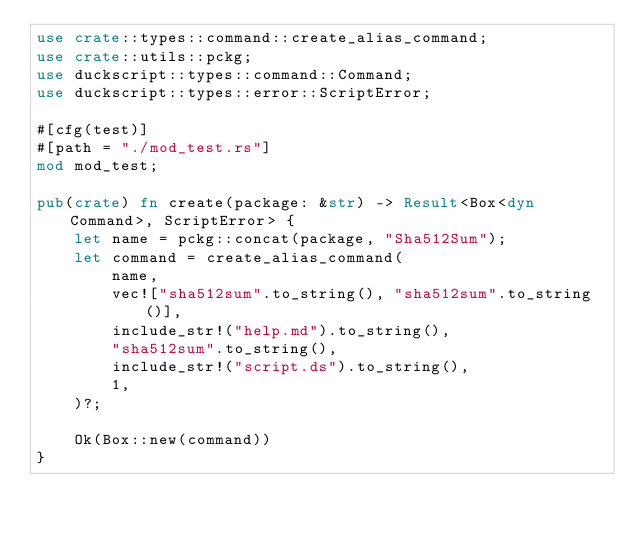<code> <loc_0><loc_0><loc_500><loc_500><_Rust_>use crate::types::command::create_alias_command;
use crate::utils::pckg;
use duckscript::types::command::Command;
use duckscript::types::error::ScriptError;

#[cfg(test)]
#[path = "./mod_test.rs"]
mod mod_test;

pub(crate) fn create(package: &str) -> Result<Box<dyn Command>, ScriptError> {
    let name = pckg::concat(package, "Sha512Sum");
    let command = create_alias_command(
        name,
        vec!["sha512sum".to_string(), "sha512sum".to_string()],
        include_str!("help.md").to_string(),
        "sha512sum".to_string(),
        include_str!("script.ds").to_string(),
        1,
    )?;

    Ok(Box::new(command))
}
</code> 